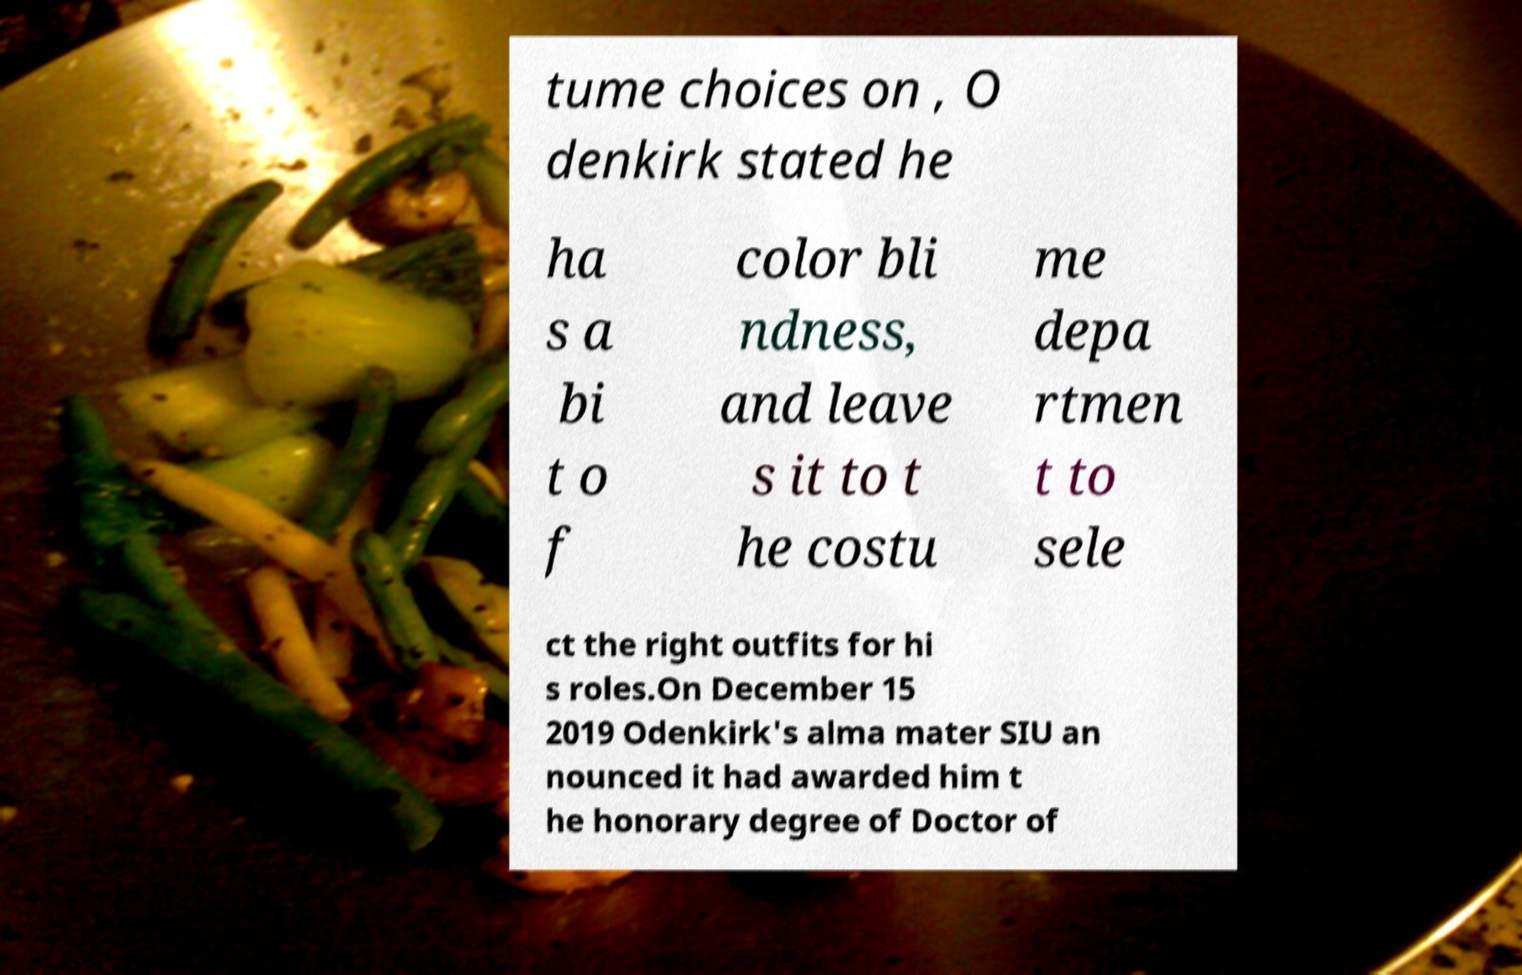Please identify and transcribe the text found in this image. tume choices on , O denkirk stated he ha s a bi t o f color bli ndness, and leave s it to t he costu me depa rtmen t to sele ct the right outfits for hi s roles.On December 15 2019 Odenkirk's alma mater SIU an nounced it had awarded him t he honorary degree of Doctor of 